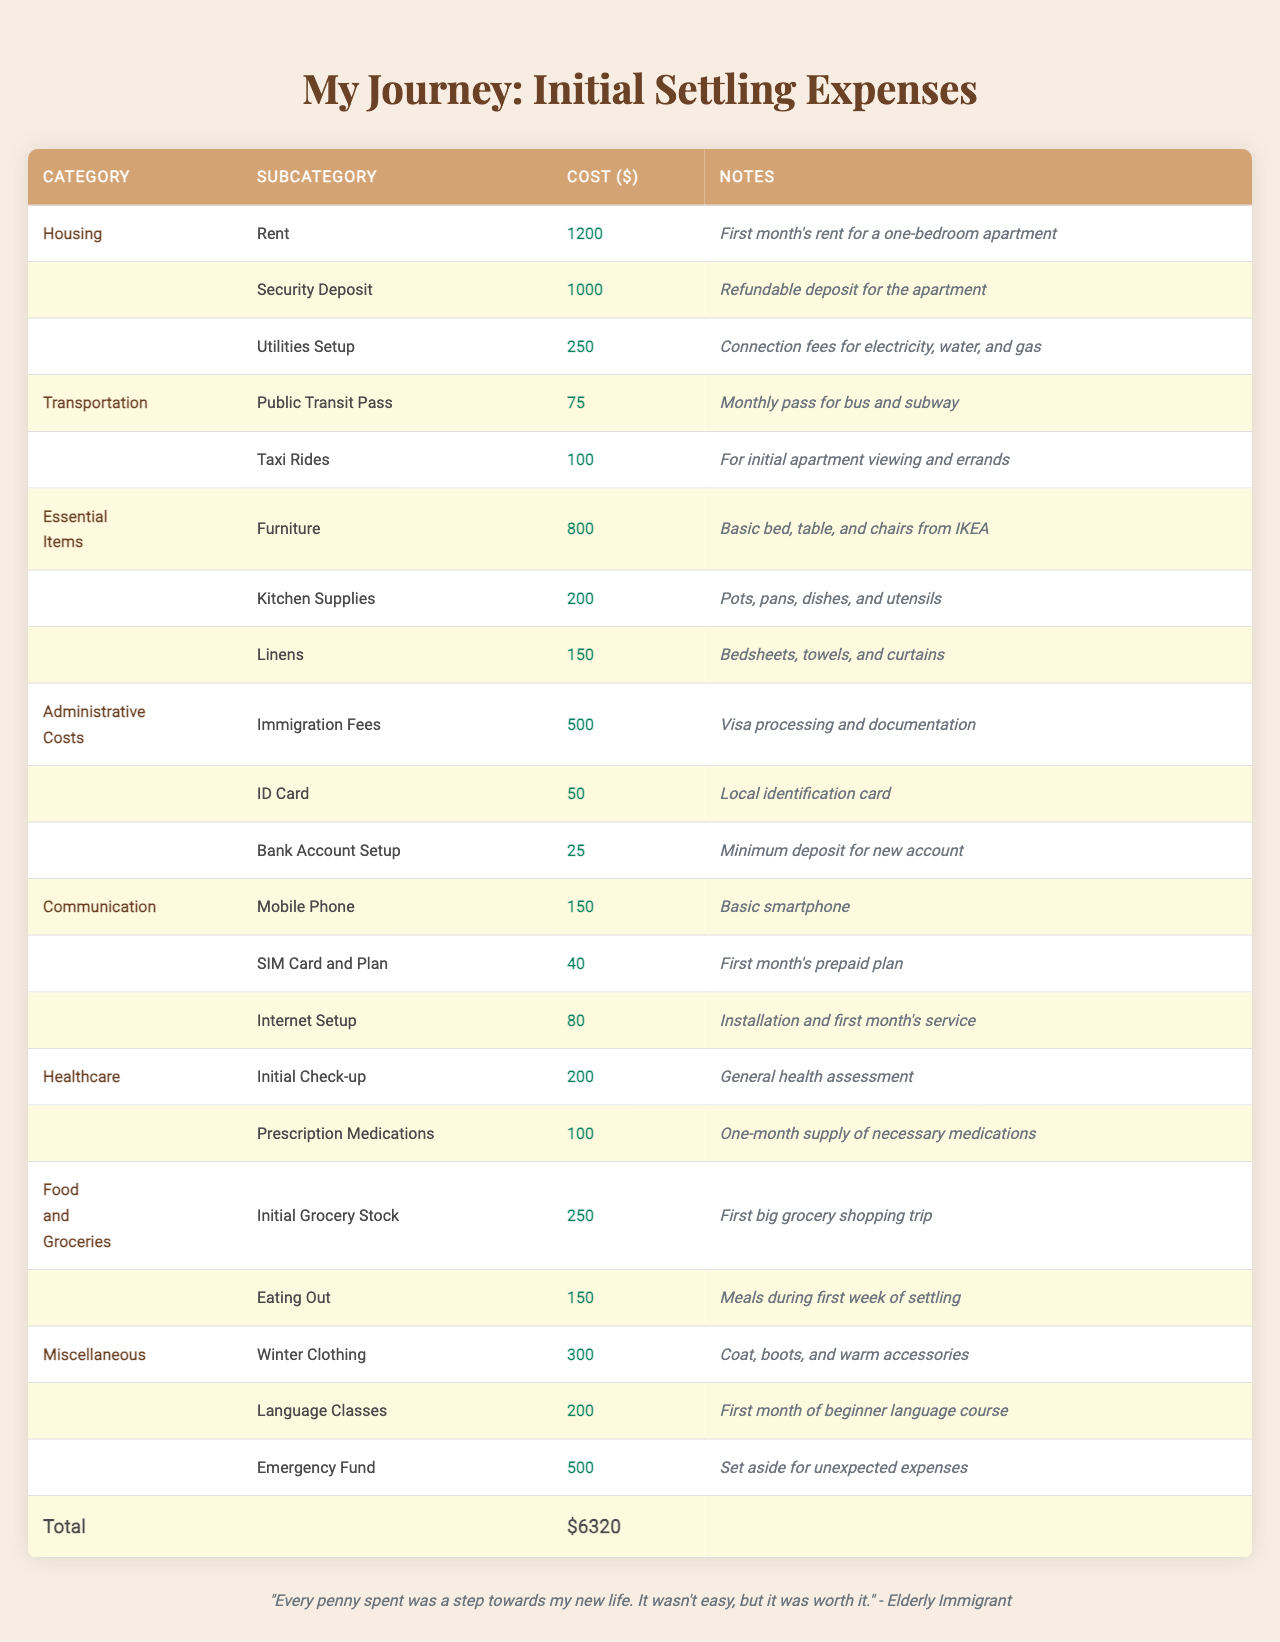What is the total cost of initial settling expenses? To find the total cost, we need to sum all the individual costs listed in each category. Adding them together gives us: 1200 + 1000 + 250 + 75 + 100 + 800 + 200 + 150 + 500 + 50 + 25 + 150 + 40 + 80 + 200 + 100 + 250 + 150 + 300 + 200 + 500 = 5750
Answer: 5750 How much did I spend on housing? The housing expenses include rent ($1200), security deposit ($1000), and utilities setup ($250). Summing these gives us: 1200 + 1000 + 250 = 2450
Answer: 2450 Are administrative costs the lowest among all categories? By comparing the administrative costs ($575) with the other categories, we find that the next lowest is transportation ($175). Therefore, administrative costs are indeed the lowest.
Answer: Yes What is the average cost for essential items? The essential items category has three expenses: furniture ($800), kitchen supplies ($200), and linens ($150). First, we sum them up: 800 + 200 + 150 = 1150. There are 3 items, so the average cost is 1150/3 ≈ 383.33.
Answer: 383.33 How much more is spent on healthcare than communication? The total spent on healthcare is 200 (initial check-up) + 100 (prescription medications) = 300. The total for communication is 150 (mobile phone) + 40 (SIM card and plan) + 80 (internet setup) = 270. The difference is: 300 - 270 = 30.
Answer: 30 What percentage of the total cost was spent on food and groceries? The total cost of food and groceries is 250 (initial grocery stock) + 150 (eating out) = 400. The total initial settling expenses is 5750. To find the percentage, we calculate (400 / 5750) * 100 ≈ 6.96%.
Answer: 6.96% Which category has the highest single expense? Reviewing the table, the highest single expense is the rent in the housing category, which costs 1200. This is higher than any single entry in all other categories.
Answer: 1200 If I had to remove the miscellaneous expenses, what would the new total be? The miscellaneous expenses amount to 300 + 200 + 500 = 1000. Subtracting this from the total initial expenses of 5750 gives us: 5750 - 1000 = 4750.
Answer: 4750 What is the total spent on healthcare and essential items combined? The total for healthcare is 200 (initial check-up) + 100 (prescription medications) = 300. For essential items, the total is 800 (furniture) + 200 (kitchen supplies) + 150 (linens) = 1150. Adding these gives us: 300 + 1150 = 1450.
Answer: 1450 How many categories are there in total? The table lists eight different categories of expenses: Housing, Transportation, Essential Items, Administrative Costs, Communication, Healthcare, Food and Groceries, and Miscellaneous. Therefore, the total number of categories is 8.
Answer: 8 